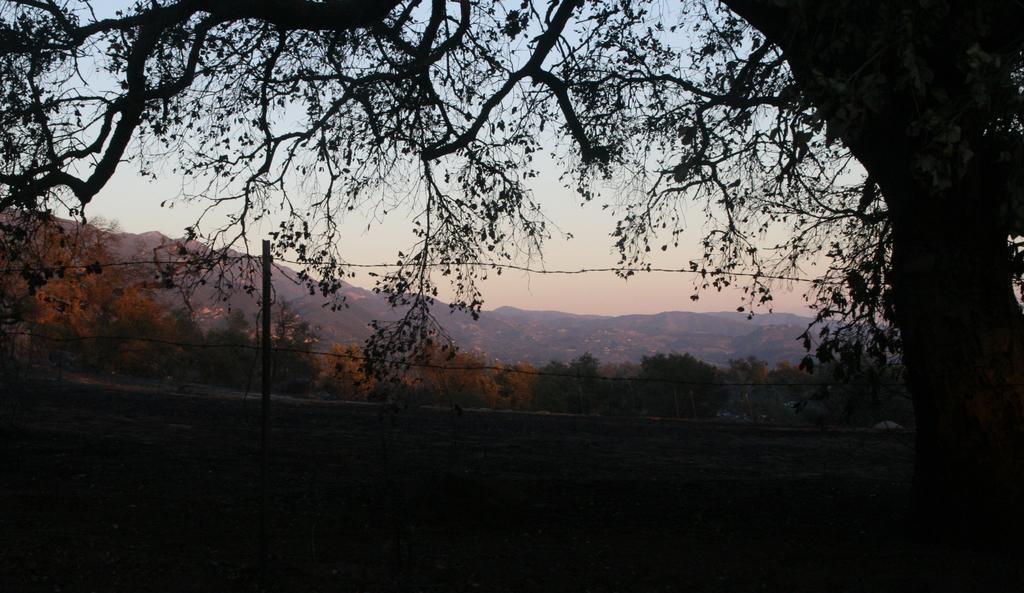Can you describe this image briefly? In this image we can see a tree, bark of a tree, pole and wires. On the backside we can see the mountains and the sky which looks cloudy. 